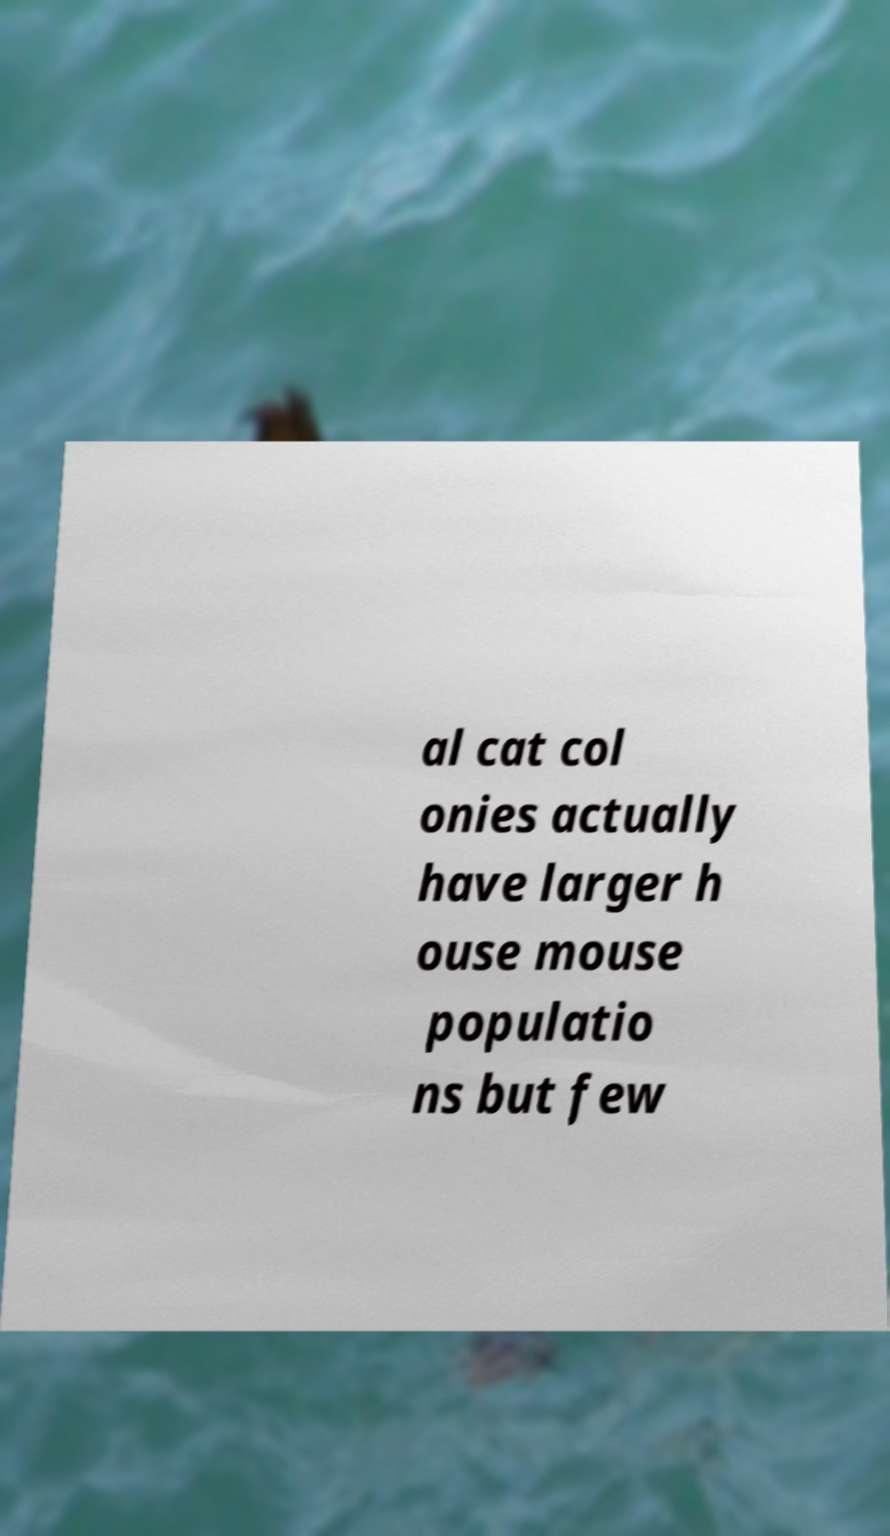Could you extract and type out the text from this image? al cat col onies actually have larger h ouse mouse populatio ns but few 